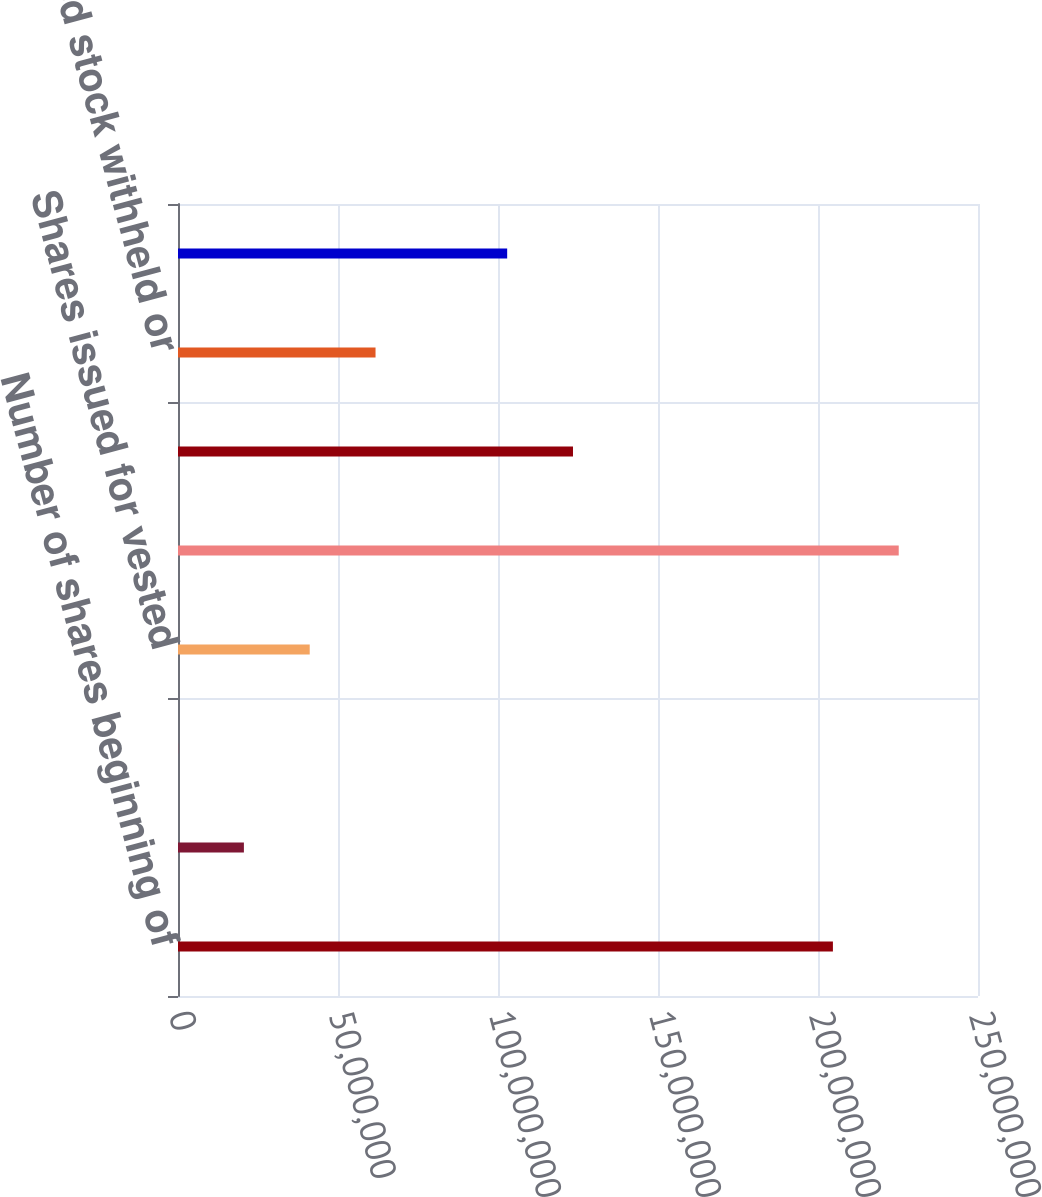Convert chart to OTSL. <chart><loc_0><loc_0><loc_500><loc_500><bar_chart><fcel>Number of shares beginning of<fcel>Restricted stock shares issued<fcel>Shares granted and issued<fcel>Shares issued for vested<fcel>Number of shares issued end of<fcel>Number of shares held<fcel>Restricted stock withheld or<fcel>Number of shares held end of<nl><fcel>2.04661e+08<fcel>2.05942e+07<fcel>25993<fcel>4.11623e+07<fcel>2.25229e+08<fcel>1.23435e+08<fcel>6.17305e+07<fcel>1.02867e+08<nl></chart> 